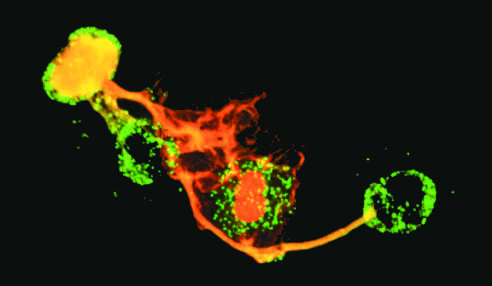whose nuclei have been lost?
Answer the question using a single word or phrase. Neutrophils 